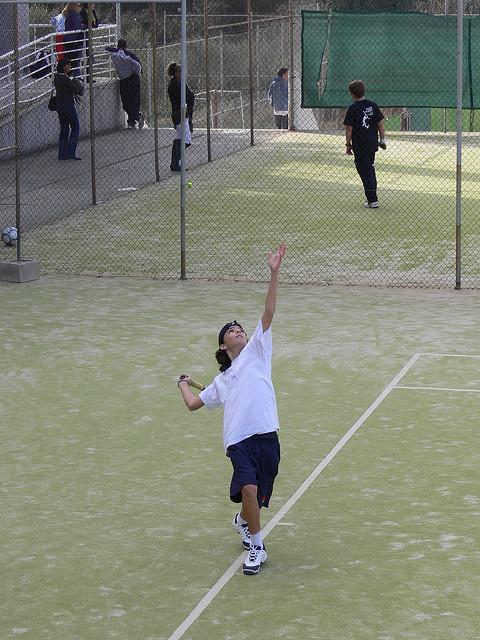Is there someone ready to serve the ball?
Concise answer only. Yes. Where was it taken?
Answer briefly. Tennis court. What sport is being played?
Short answer required. Tennis. 